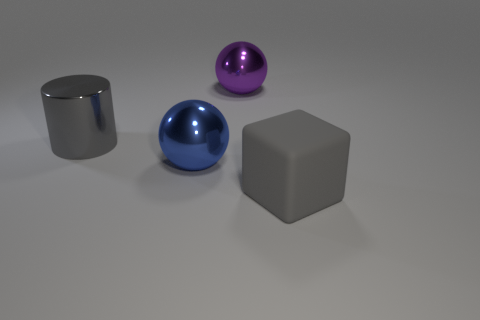What different shapes can you identify in this image, and how would you describe their arrangement? In the image, there are three distinctly different shapes: a sphere, a cylinder, and a cube. The blue sphere and purple sphere look glossy, suggesting they could be made of a similar material like polished metal or glass. The cylinder and cube have similar surface characteristics. They're arranged with ample space between them, on a flat surface, creating a simple yet harmonious composition. 